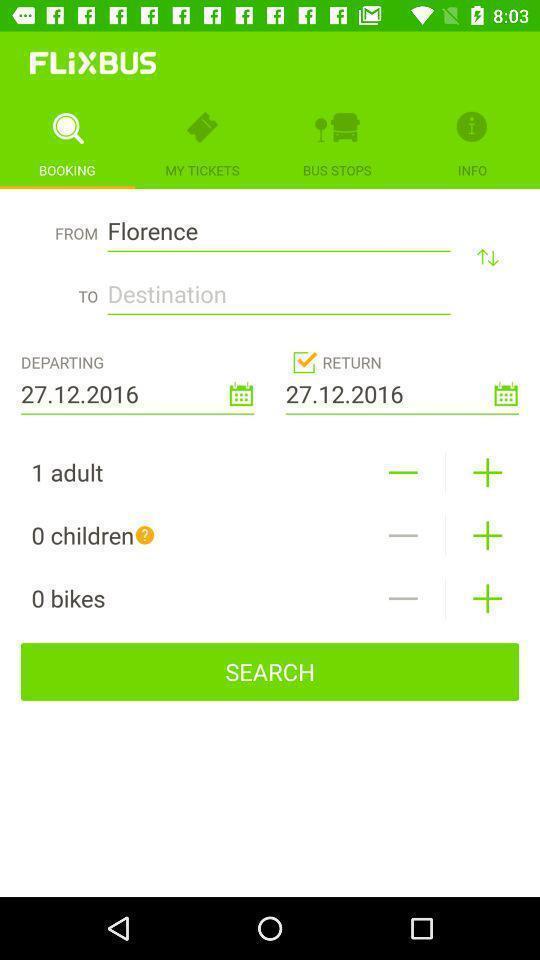Describe the key features of this screenshot. Page showing search bar to find tickets available for booking. 